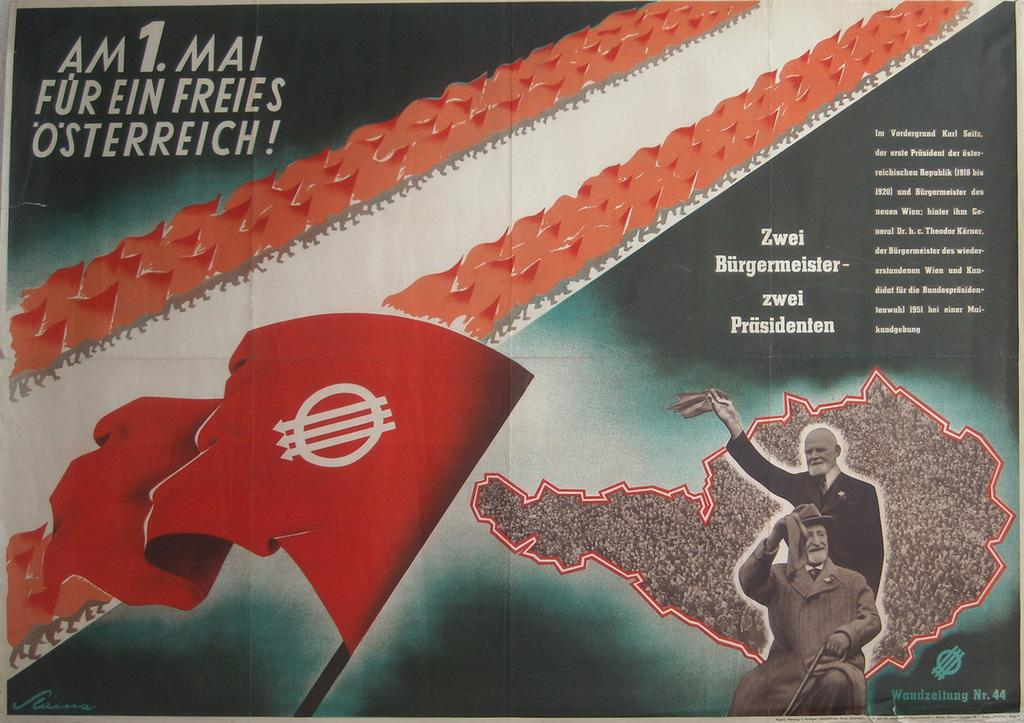<image>
Share a concise interpretation of the image provided. An article that was written regarding freeing Austria, in french has two men celebrating in the bottom right corner and a flag in the center, left corner. 